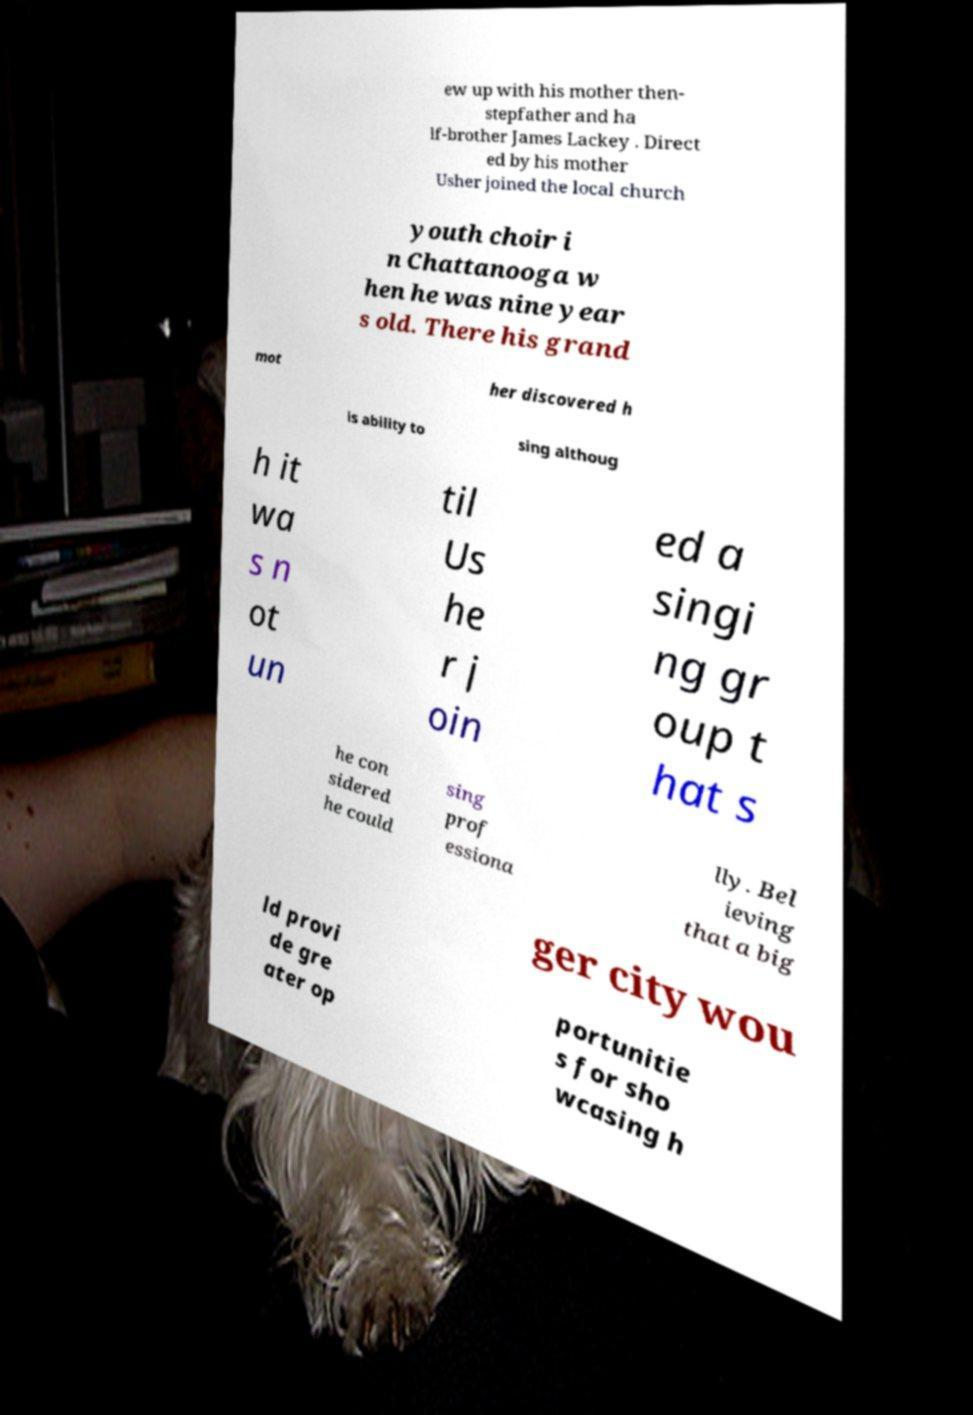For documentation purposes, I need the text within this image transcribed. Could you provide that? ew up with his mother then- stepfather and ha lf-brother James Lackey . Direct ed by his mother Usher joined the local church youth choir i n Chattanooga w hen he was nine year s old. There his grand mot her discovered h is ability to sing althoug h it wa s n ot un til Us he r j oin ed a singi ng gr oup t hat s he con sidered he could sing prof essiona lly. Bel ieving that a big ger city wou ld provi de gre ater op portunitie s for sho wcasing h 